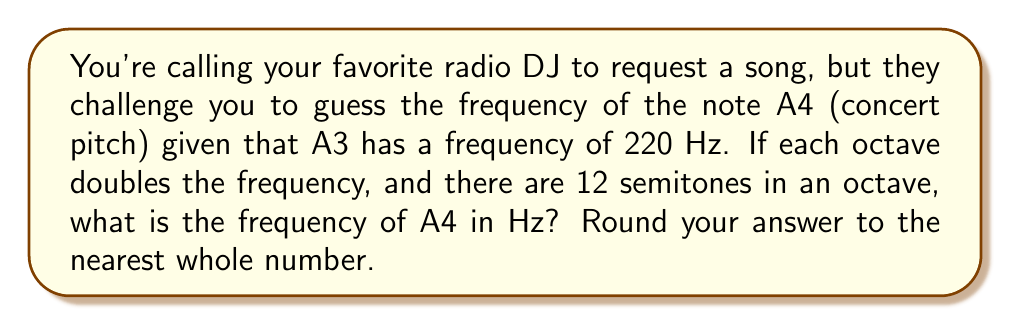Show me your answer to this math problem. Let's approach this step-by-step:

1) We know that A3 has a frequency of 220 Hz, and we need to find A4, which is one octave higher.

2) Each octave doubles the frequency, so A4 will have twice the frequency of A3:
   $$f_{A4} = 2 \times f_{A3} = 2 \times 220 = 440 \text{ Hz}$$

3) However, to demonstrate the use of logarithmic scales, let's solve this using the formula for frequency based on semitones:

   $$f = f_0 \times 2^{\frac{n}{12}}$$

   Where:
   $f$ is the frequency we're looking for
   $f_0$ is the reference frequency (220 Hz in this case)
   $n$ is the number of semitones between the notes (12 for one octave)

4) Plugging in our values:

   $$f = 220 \times 2^{\frac{12}{12}}$$

5) Simplify:
   $$f = 220 \times 2^1 = 220 \times 2 = 440 \text{ Hz}$$

6) Round to the nearest whole number: 440 Hz

This method using logarithmic scales allows us to calculate the frequency of any note given a reference frequency and the number of semitones between them.
Answer: 440 Hz 